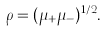Convert formula to latex. <formula><loc_0><loc_0><loc_500><loc_500>\rho = ( \mu _ { + } \mu _ { - } ) ^ { 1 / 2 } .</formula> 